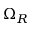Convert formula to latex. <formula><loc_0><loc_0><loc_500><loc_500>\Omega _ { R }</formula> 